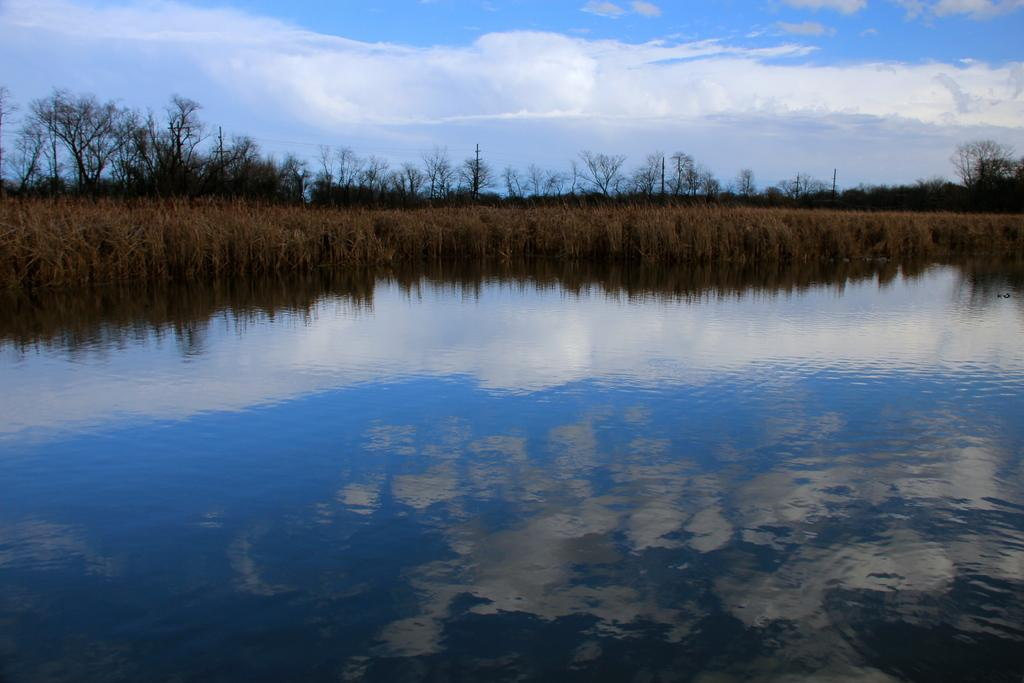What is at the bottom of the image? There is water at the bottom of the image. What type of vegetation is behind the water? There is grass behind the water. What else can be seen in the image besides water and grass? There are trees in the image. What is visible at the top of the image? The sky is visible at the top of the image. What can be observed in the sky? Clouds are present in the sky. How many snakes are slithering through the grass in the image? There are no snakes present in the image; it features water, grass, trees, and a sky with clouds. What type of rake is being used to gather leaves in the image? There is no rake present in the image, as it focuses on natural elements such as water, grass, trees, and the sky. 